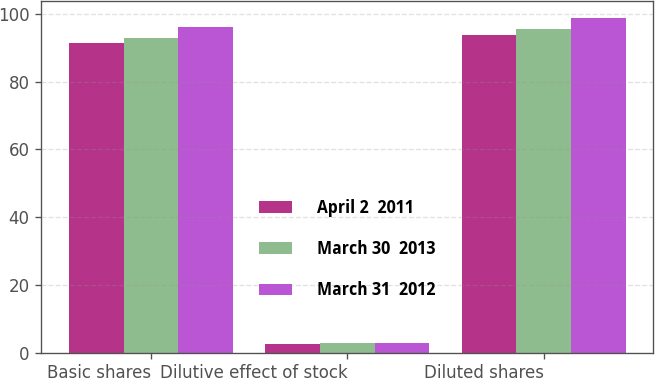<chart> <loc_0><loc_0><loc_500><loc_500><stacked_bar_chart><ecel><fcel>Basic shares<fcel>Dilutive effect of stock<fcel>Diluted shares<nl><fcel>April 2  2011<fcel>91.3<fcel>2.4<fcel>93.7<nl><fcel>March 30  2013<fcel>92.7<fcel>2.8<fcel>95.5<nl><fcel>March 31  2012<fcel>96<fcel>2.7<fcel>98.7<nl></chart> 